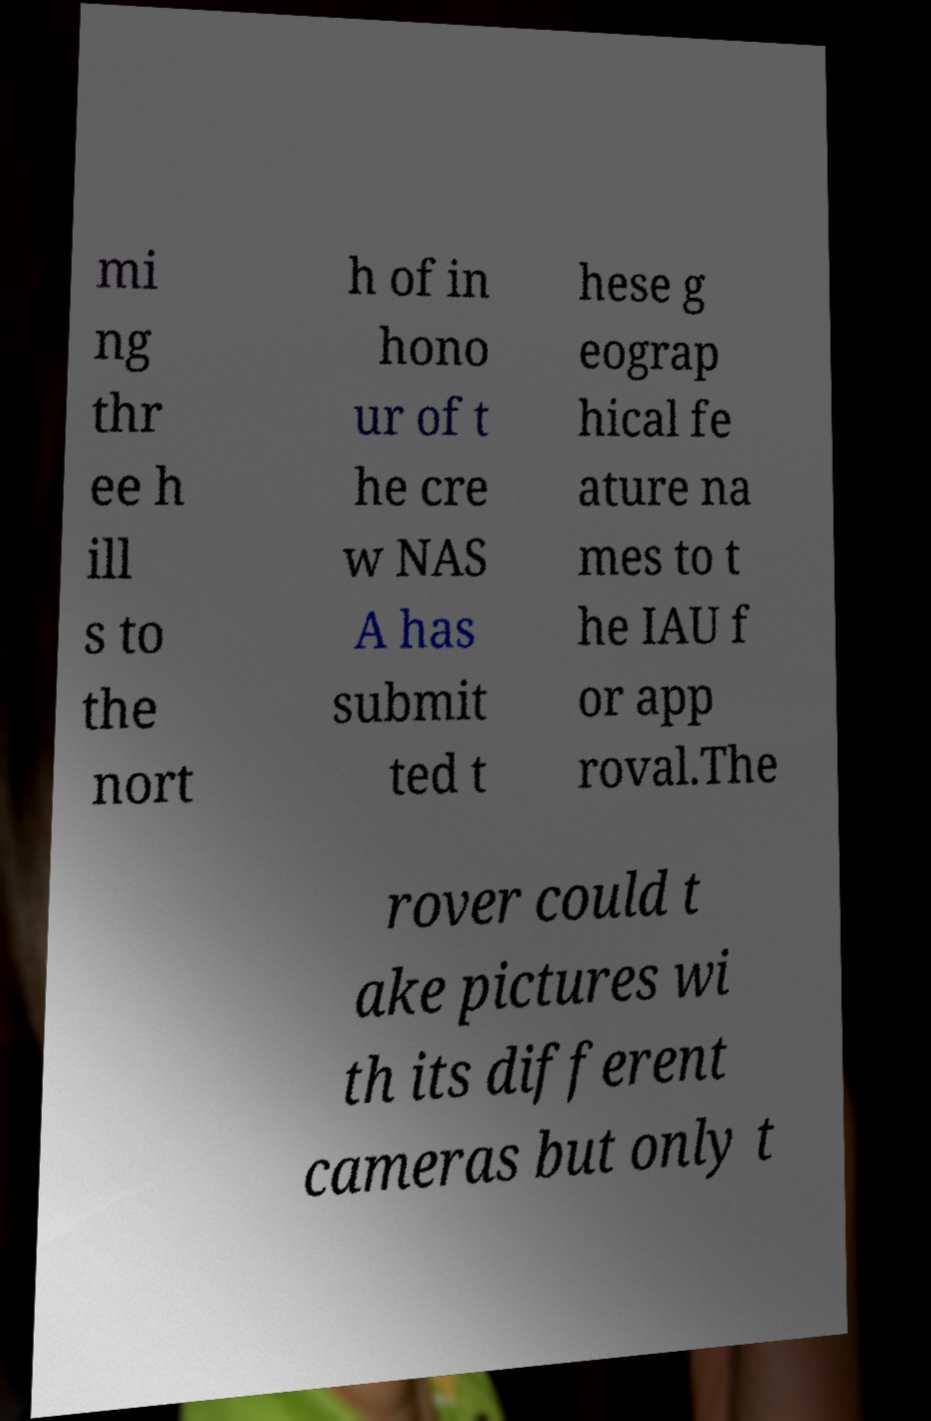What messages or text are displayed in this image? I need them in a readable, typed format. mi ng thr ee h ill s to the nort h of in hono ur of t he cre w NAS A has submit ted t hese g eograp hical fe ature na mes to t he IAU f or app roval.The rover could t ake pictures wi th its different cameras but only t 